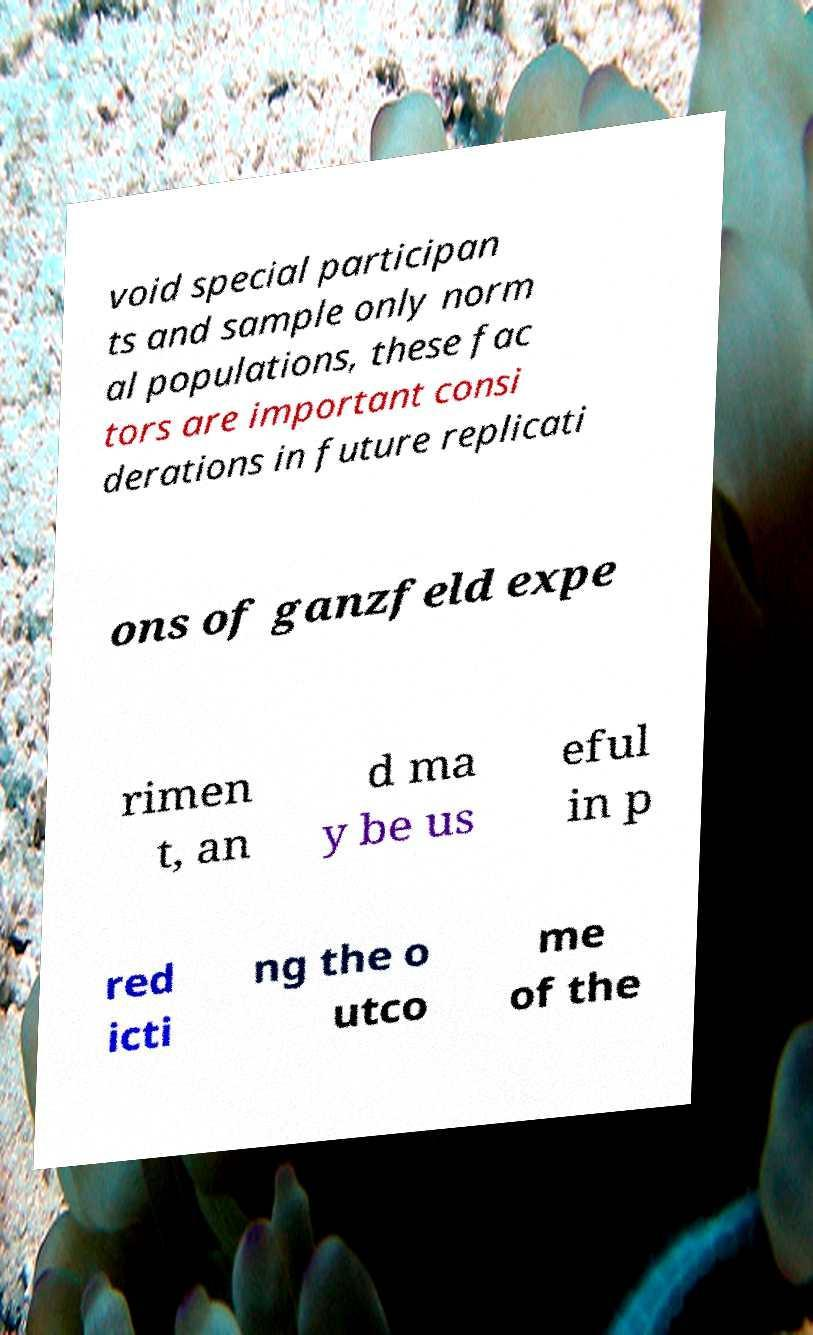I need the written content from this picture converted into text. Can you do that? void special participan ts and sample only norm al populations, these fac tors are important consi derations in future replicati ons of ganzfeld expe rimen t, an d ma y be us eful in p red icti ng the o utco me of the 